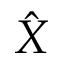<formula> <loc_0><loc_0><loc_500><loc_500>\hat { X }</formula> 